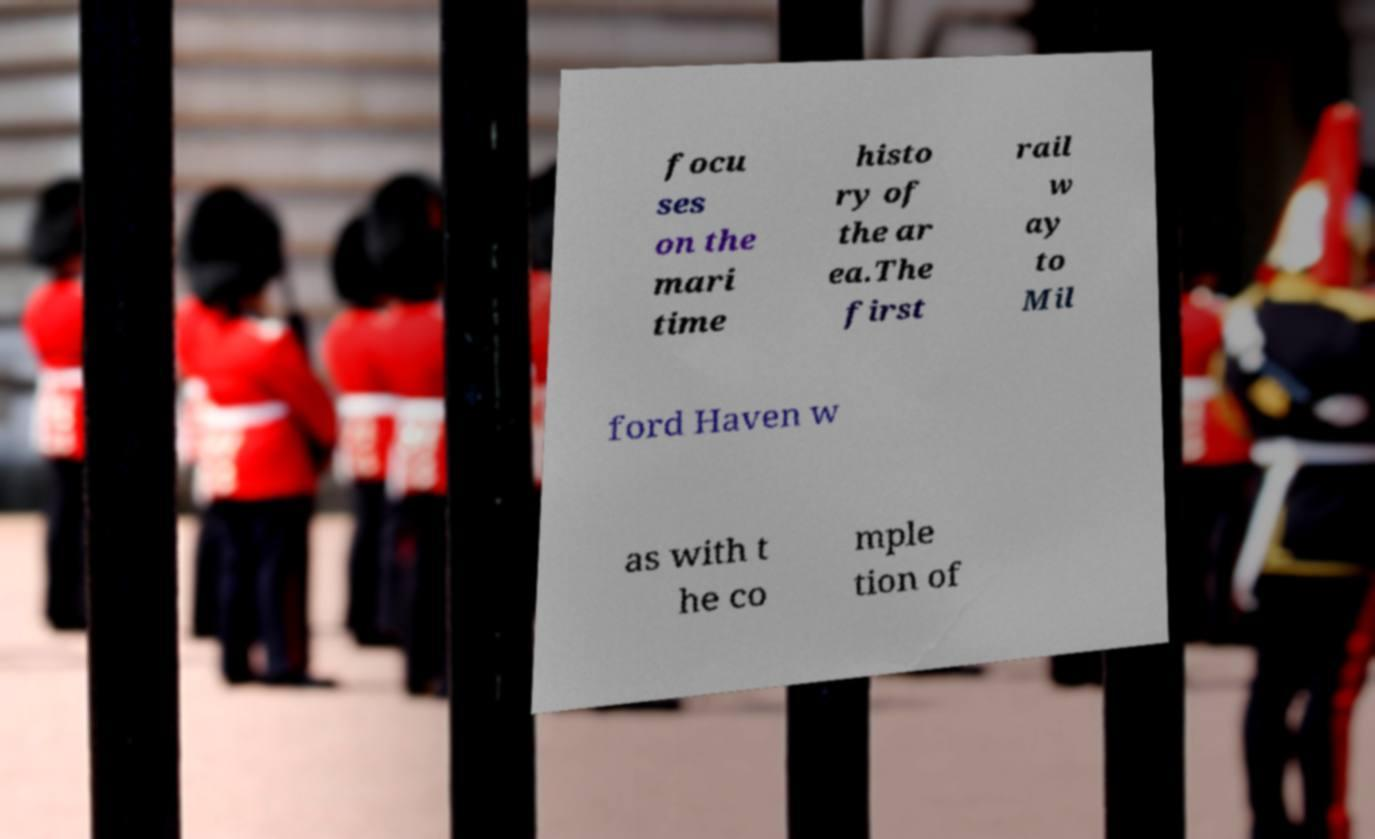Can you read and provide the text displayed in the image?This photo seems to have some interesting text. Can you extract and type it out for me? focu ses on the mari time histo ry of the ar ea.The first rail w ay to Mil ford Haven w as with t he co mple tion of 